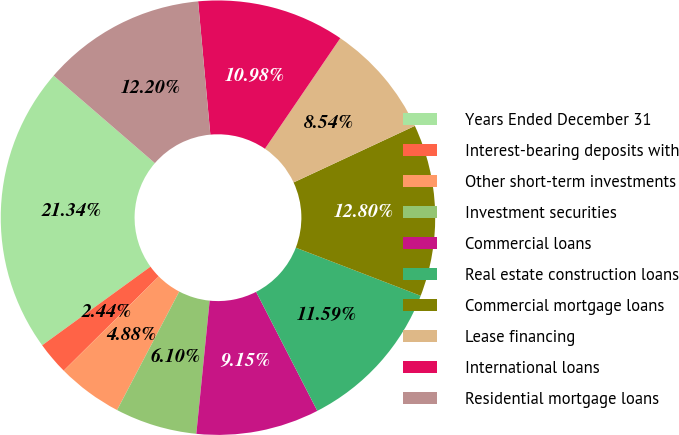<chart> <loc_0><loc_0><loc_500><loc_500><pie_chart><fcel>Years Ended December 31<fcel>Interest-bearing deposits with<fcel>Other short-term investments<fcel>Investment securities<fcel>Commercial loans<fcel>Real estate construction loans<fcel>Commercial mortgage loans<fcel>Lease financing<fcel>International loans<fcel>Residential mortgage loans<nl><fcel>21.34%<fcel>2.44%<fcel>4.88%<fcel>6.1%<fcel>9.15%<fcel>11.59%<fcel>12.8%<fcel>8.54%<fcel>10.98%<fcel>12.2%<nl></chart> 